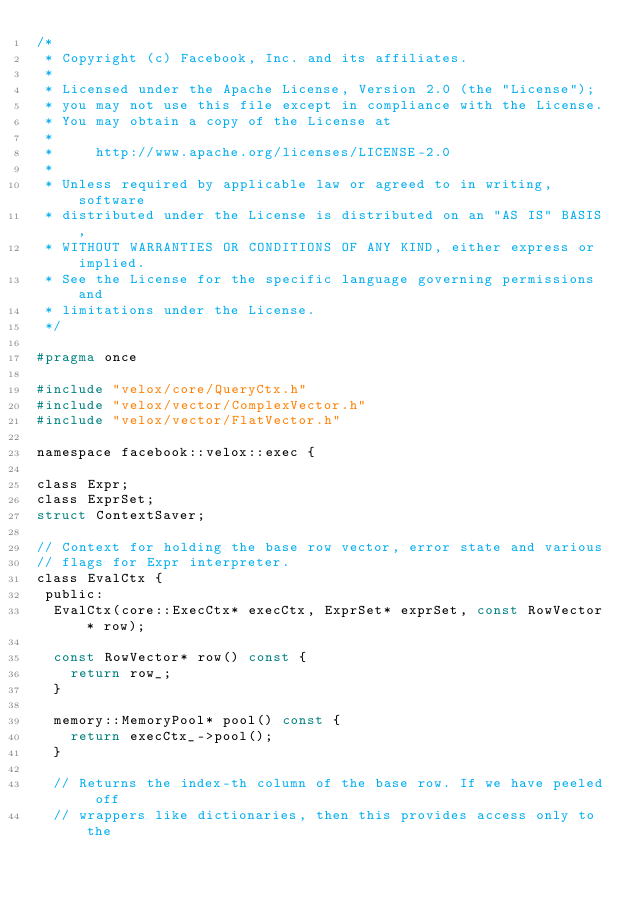Convert code to text. <code><loc_0><loc_0><loc_500><loc_500><_C_>/*
 * Copyright (c) Facebook, Inc. and its affiliates.
 *
 * Licensed under the Apache License, Version 2.0 (the "License");
 * you may not use this file except in compliance with the License.
 * You may obtain a copy of the License at
 *
 *     http://www.apache.org/licenses/LICENSE-2.0
 *
 * Unless required by applicable law or agreed to in writing, software
 * distributed under the License is distributed on an "AS IS" BASIS,
 * WITHOUT WARRANTIES OR CONDITIONS OF ANY KIND, either express or implied.
 * See the License for the specific language governing permissions and
 * limitations under the License.
 */

#pragma once

#include "velox/core/QueryCtx.h"
#include "velox/vector/ComplexVector.h"
#include "velox/vector/FlatVector.h"

namespace facebook::velox::exec {

class Expr;
class ExprSet;
struct ContextSaver;

// Context for holding the base row vector, error state and various
// flags for Expr interpreter.
class EvalCtx {
 public:
  EvalCtx(core::ExecCtx* execCtx, ExprSet* exprSet, const RowVector* row);

  const RowVector* row() const {
    return row_;
  }

  memory::MemoryPool* pool() const {
    return execCtx_->pool();
  }

  // Returns the index-th column of the base row. If we have peeled off
  // wrappers like dictionaries, then this provides access only to the</code> 